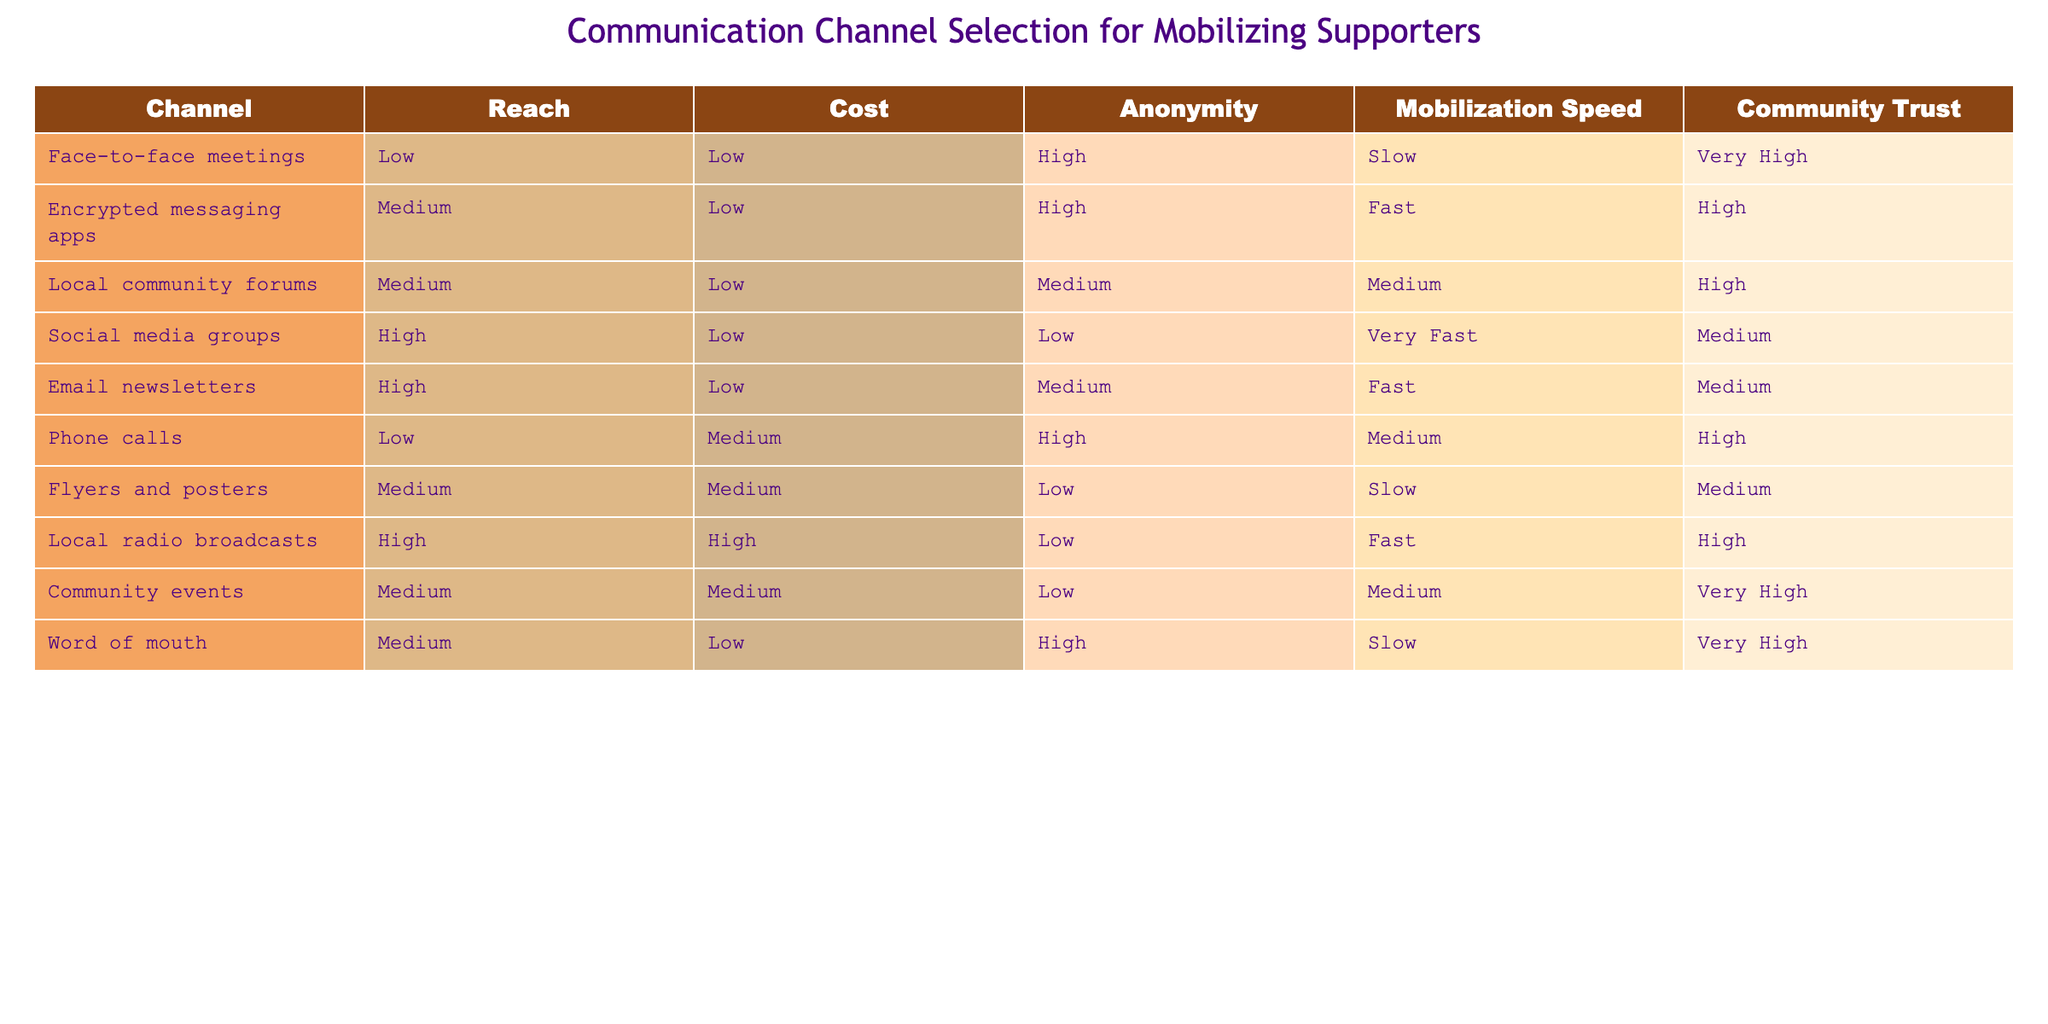What is the reach level of social media groups? In the table, the reach level column indicates that social media groups have a "High" reach level.
Answer: High Which communication channels have low cost? The channels that have a low cost are: face-to-face meetings, encrypted messaging apps, local community forums, social media groups, and email newsletters. There are five channels matching the criteria.
Answer: 5 Is there any channel with very high community trust? By reviewing the community trust column, both face-to-face meetings and word of mouth are marked as having "Very High" community trust. Therefore, the answer is yes.
Answer: Yes What is the mobilization speed of local community forums? Looking at the mobilization speed column, local community forums are indicated as having a "Medium" mobilization speed.
Answer: Medium Which channel has the highest reach and what is its mobilization speed? Examining the reach column, social media groups have the highest reach marked as "High". Their mobilization speed, as noted in the table, is "Very Fast", confirming both points.
Answer: High reach, Very Fast mobilization speed If the goal is quick mobilization with high community trust, which channels should be prioritized? Analyzing the table for channels with fast mobilization speed, only encrypted messaging apps and local radio broadcasts offer "Fast" mobilization. Yet, only encrypted messaging apps have high community trust while local radio broadcasts do not meet the trust criteria. Hence, "encrypted messaging apps" is the preferred choice for the goal.
Answer: Encrypted messaging apps How many channels offer anonymity? Reviewing the anonymity column reveals that four channels have "High" anonymity: face-to-face meetings, encrypted messaging apps, phone calls, and word of mouth. Therefore, there are four channels with high anonymity.
Answer: 4 What is the cost difference between social media groups and local radio broadcasts? From the cost column, social media groups have "Low" cost while local radio broadcasts have "High" cost. The difference in cost indicates that social media groups are more economical than local radio broadcasts, thus identifying one as low and the other as high.
Answer: Low cost, High cost 